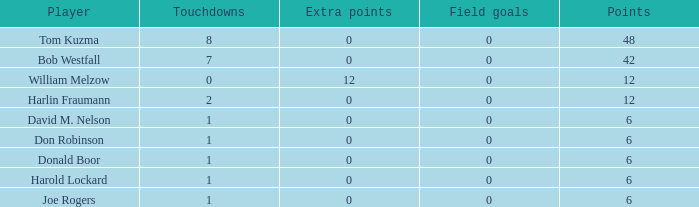Name the points for donald boor 6.0. 